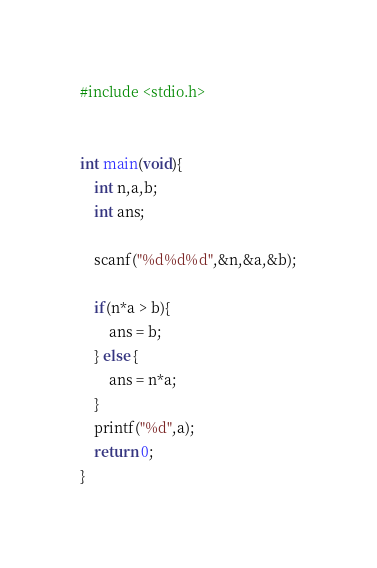Convert code to text. <code><loc_0><loc_0><loc_500><loc_500><_C_>#include <stdio.h>


int main(void){
    int n,a,b;
    int ans;

    scanf("%d%d%d",&n,&a,&b);
    
    if(n*a > b){
        ans = b;
    } else {
        ans = n*a;
    }
    printf("%d",a);
    return 0;
}</code> 